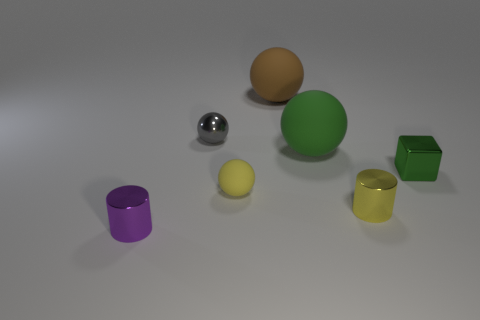Add 3 small metallic blocks. How many objects exist? 10 Subtract all blocks. How many objects are left? 6 Subtract all green rubber things. Subtract all tiny balls. How many objects are left? 4 Add 1 big green rubber objects. How many big green rubber objects are left? 2 Add 4 tiny gray metal spheres. How many tiny gray metal spheres exist? 5 Subtract 1 green cubes. How many objects are left? 6 